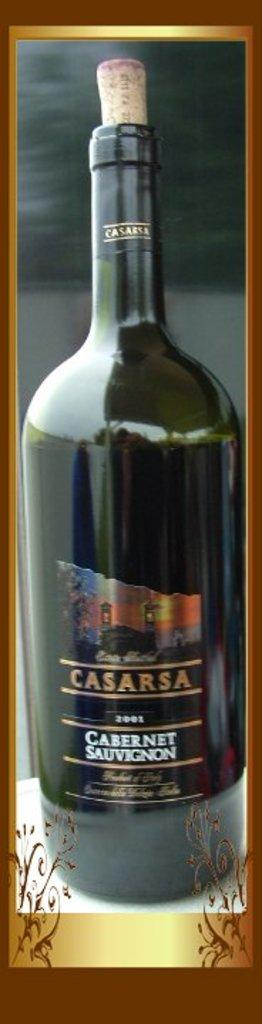Provide a one-sentence caption for the provided image. Bottle of Casarsa wine is sitting on the window sill. 